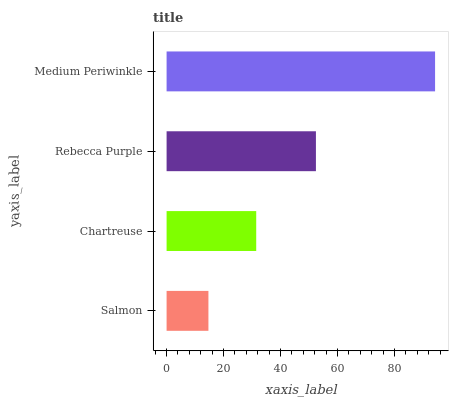Is Salmon the minimum?
Answer yes or no. Yes. Is Medium Periwinkle the maximum?
Answer yes or no. Yes. Is Chartreuse the minimum?
Answer yes or no. No. Is Chartreuse the maximum?
Answer yes or no. No. Is Chartreuse greater than Salmon?
Answer yes or no. Yes. Is Salmon less than Chartreuse?
Answer yes or no. Yes. Is Salmon greater than Chartreuse?
Answer yes or no. No. Is Chartreuse less than Salmon?
Answer yes or no. No. Is Rebecca Purple the high median?
Answer yes or no. Yes. Is Chartreuse the low median?
Answer yes or no. Yes. Is Medium Periwinkle the high median?
Answer yes or no. No. Is Rebecca Purple the low median?
Answer yes or no. No. 